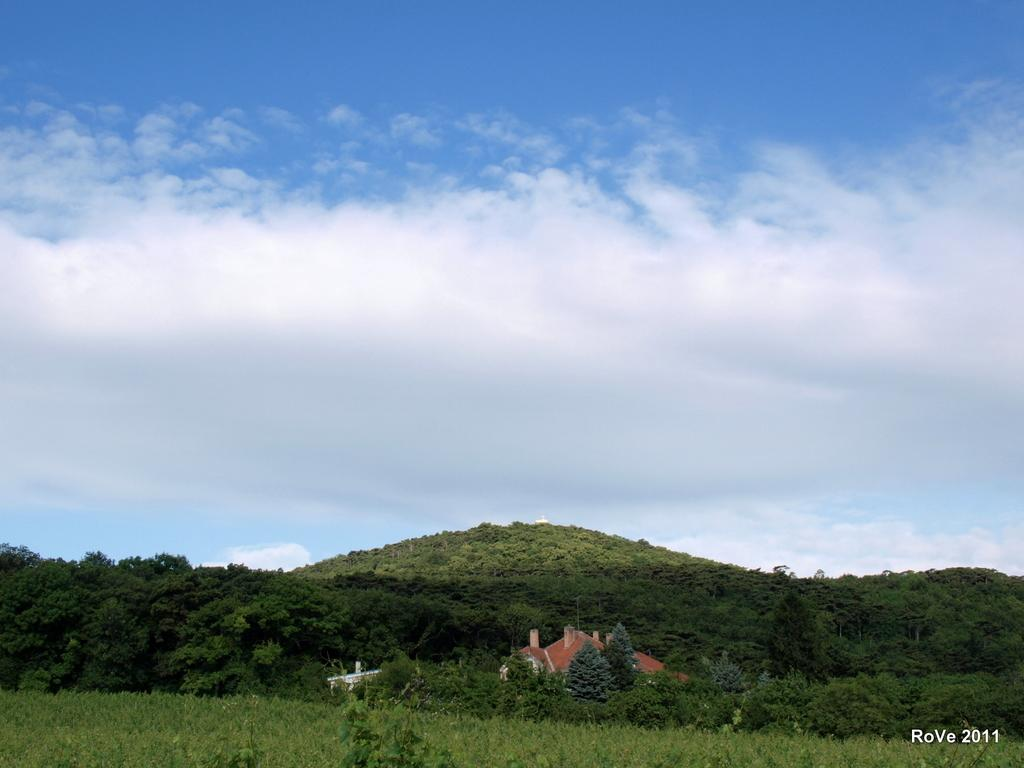What type of vegetation is present on the ground in the image? There is grass on the ground in the front of the image. What can be seen in the background of the image? There are trees in the background of the image. How would you describe the sky in the image? The sky is cloudy in the image. How many cows are grazing in the grass in the image? There are no cows present in the image; it only features grass on the ground. What type of building can be seen near the trees in the image? There is no building visible in the image; it only features trees in the background. 